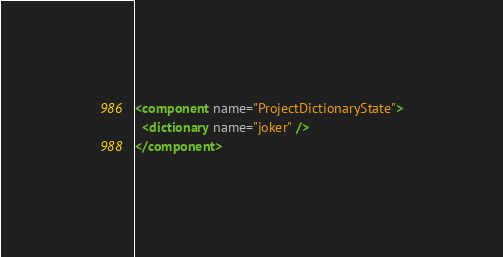<code> <loc_0><loc_0><loc_500><loc_500><_XML_><component name="ProjectDictionaryState">
  <dictionary name="joker" />
</component></code> 